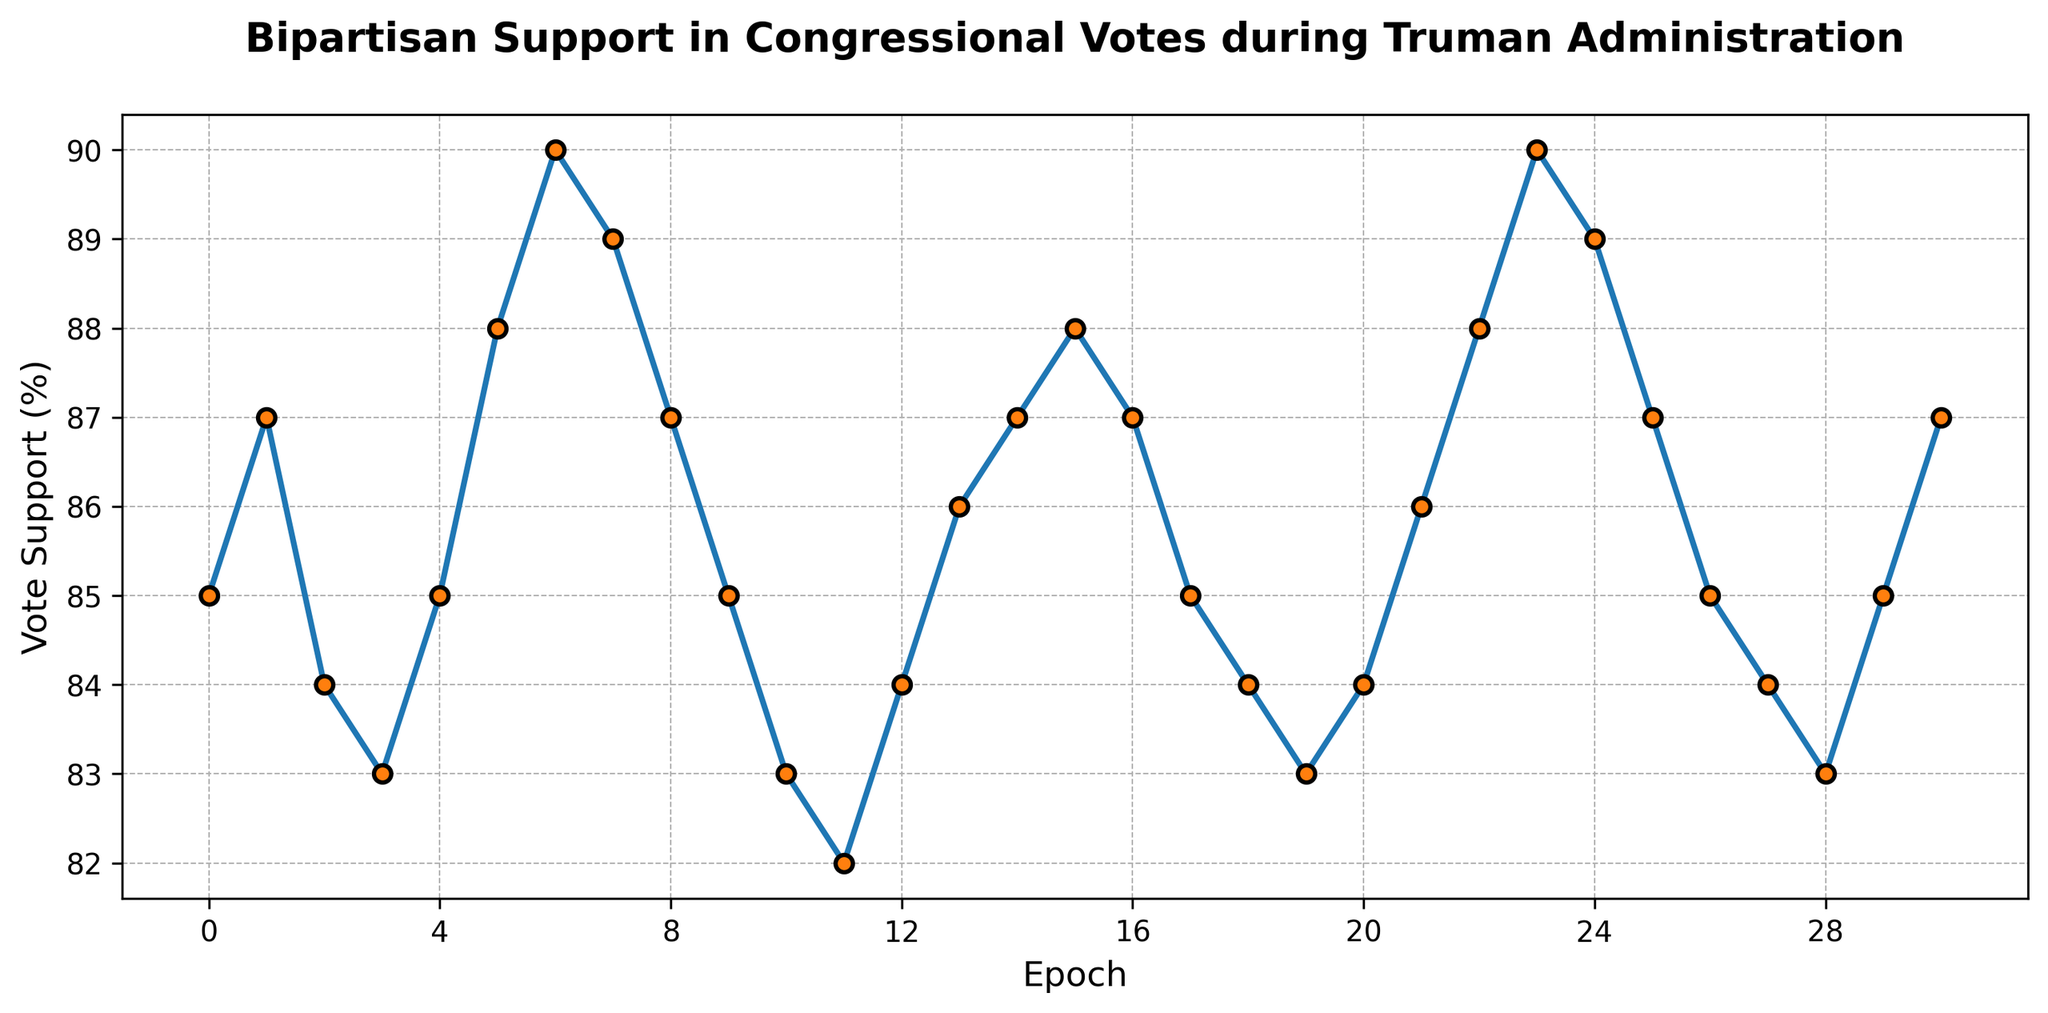What's the average vote support during the Truman administration as shown in the figure? To find the average vote support, sum up all the vote support values and then divide by the number of points. The values are: [85 + 87 + 84 + 83 + 85 + 88 + 90 + 89 + 87 + 85 + 83 + 82 + 84 + 86 + 87 + 88 + 87 + 85 + 84 + 83 + 84 + 86 + 88 + 90 + 89 + 87 + 85 + 84 + 83 + 85 + 87] = 2560. There are 31 data points, so the average is 2560 / 31 = 82.58.
Answer: 82.58 Which epoch had the highest vote support? By looking at the plot, identify the epoch with the highest peak on the y-axis. The highest peak of vote support is 90, which occurs at epoch 6 and 23.
Answer: 6 and 23 Is the vote support more often increasing or decreasing across epochs? By observing the trend line, tabulate each increase and decrease. There are 14 increases: epochs 0-1, 3-5, 5-6, 8-9, 10-12, 12-13; and 13 decreases: 9-10, 14-16, 17-18, 19-20, and 23-28. Thus, the vote support increases more often than it decreases.
Answer: Increasing What is the total change in vote support from the first epoch to the last epoch? Find the difference between the vote support at the first and the last epoch. The first epoch has a vote support of 85, and the last epoch has a vote support of 87. The total change is 87 - 85.
Answer: 2 How many times does the vote support drop below 85? Count the number of epochs where the vote support is below 85. Checking the values: 3, 10, 11, 12, 27, 28 -> yields a count of 6 instances.
Answer: 6 Between which epochs did the vote support show the largest increase? Check the difference between each sequential pair of epochs and determine the maximum difference: (88-85) between epochs 4 and 5 is +3, and similarly for both epochs 12-13 and 21-22.
Answer: 4-5, 12-13, 21-22 What is the median vote support? Arrange the vote support values in ascending order and find the middle one. Since there are 31 values, the median is the 16th value. Ordered data gives the 16th value as 85.
Answer: 85 Which epoch had the lowest vote support? By looking at the plot, identify the epoch with the tiniest peak on the y-axis. The lowest vote support is 82, which occurs at epoch 11.
Answer: 11 Is the trend of vote support approximately cyclic? By observing the general pattern on the plot, note the repetitive increases and decreases, indicating a sinusoidal or cyclic pattern.
Answer: Yes 